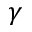Convert formula to latex. <formula><loc_0><loc_0><loc_500><loc_500>\gamma</formula> 